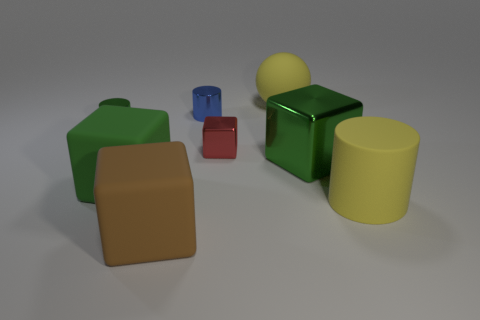The small blue thing that is to the left of the red shiny block has what shape?
Offer a very short reply. Cylinder. There is a block that is to the right of the yellow sphere; are there any matte cylinders that are in front of it?
Offer a terse response. Yes. Is there a cube that has the same size as the ball?
Your answer should be very brief. Yes. There is a shiny thing to the left of the brown rubber cube; is it the same color as the large metal thing?
Make the answer very short. Yes. What size is the green shiny cylinder?
Your response must be concise. Small. How big is the blue thing behind the cylinder right of the red block?
Give a very brief answer. Small. What number of spheres have the same color as the matte cylinder?
Give a very brief answer. 1. What number of small shiny objects are there?
Provide a short and direct response. 3. What number of yellow objects have the same material as the red object?
Make the answer very short. 0. There is a green rubber object that is the same shape as the big green metal thing; what size is it?
Your answer should be compact. Large. 